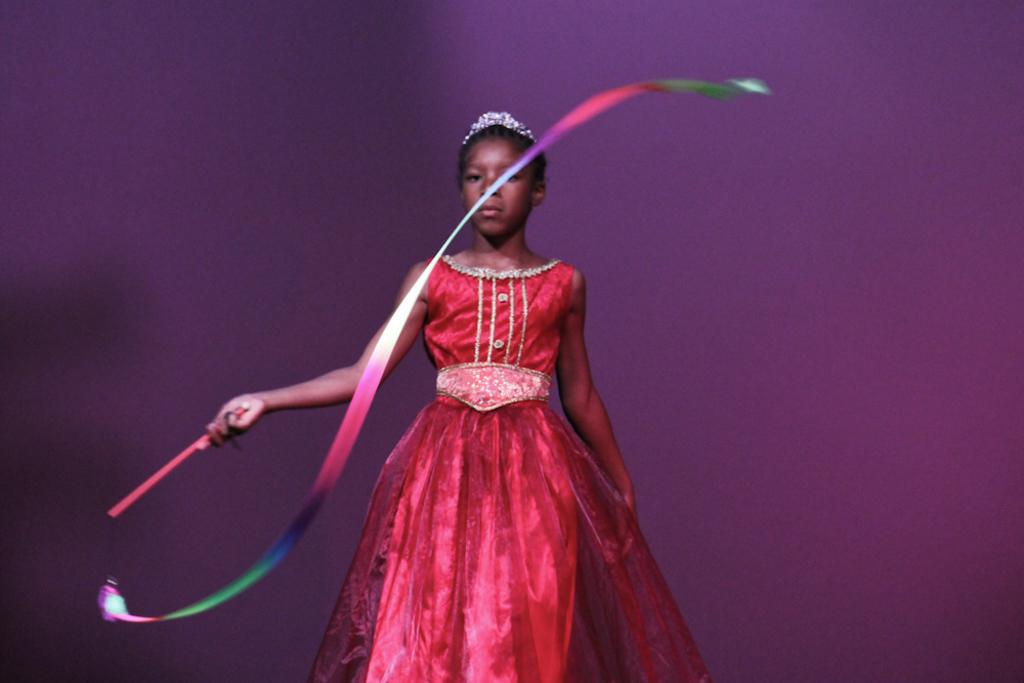Who is the main subject in the image? There is a girl in the image. Where is the girl located in the image? The girl is in the center of the image. What is the girl holding in her hand? The girl is holding a colorful ribbon in her hand. What type of suit is the girl wearing in the image? There is no mention of a suit in the provided facts, and the girl's clothing is not described. 